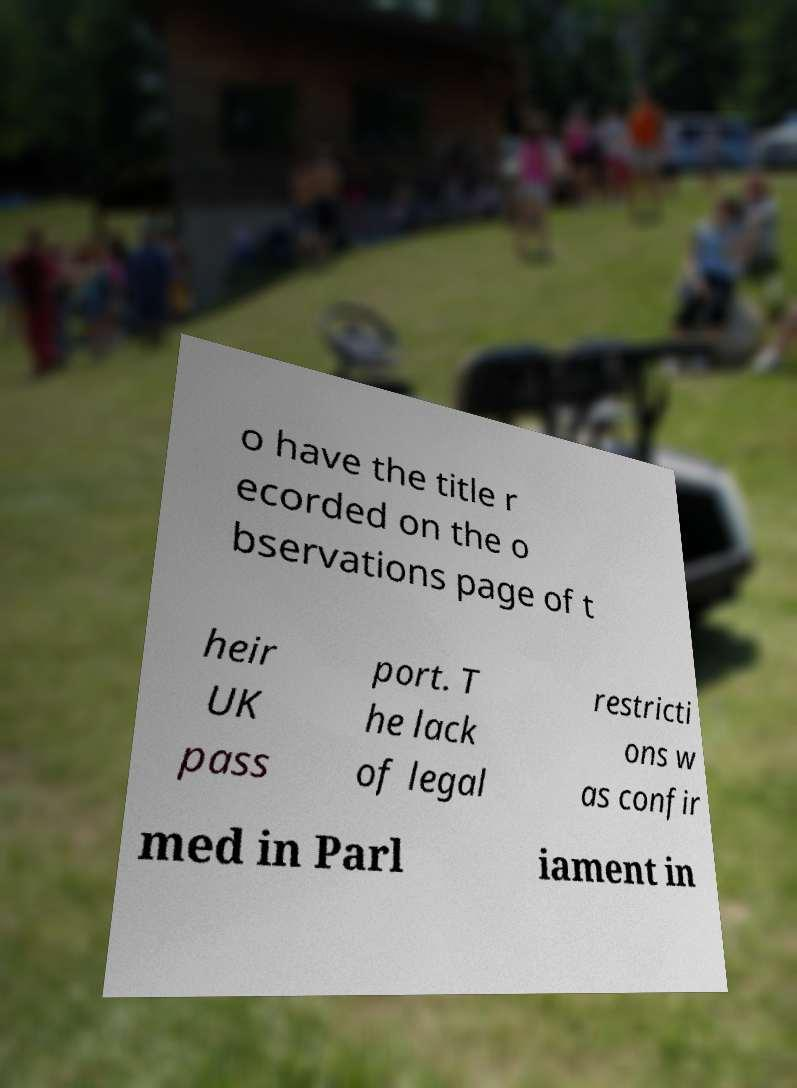Could you extract and type out the text from this image? o have the title r ecorded on the o bservations page of t heir UK pass port. T he lack of legal restricti ons w as confir med in Parl iament in 